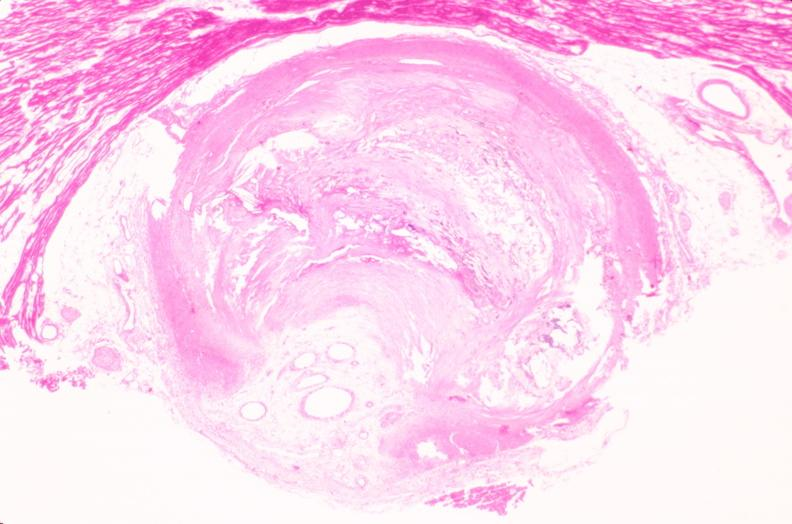does carcinomatosis show coronary artery atherosclerosis?
Answer the question using a single word or phrase. No 